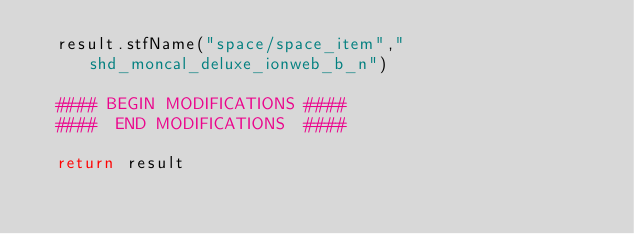<code> <loc_0><loc_0><loc_500><loc_500><_Python_>	result.stfName("space/space_item","shd_moncal_deluxe_ionweb_b_n")		
	
	#### BEGIN MODIFICATIONS ####
	####  END MODIFICATIONS  ####
	
	return result</code> 